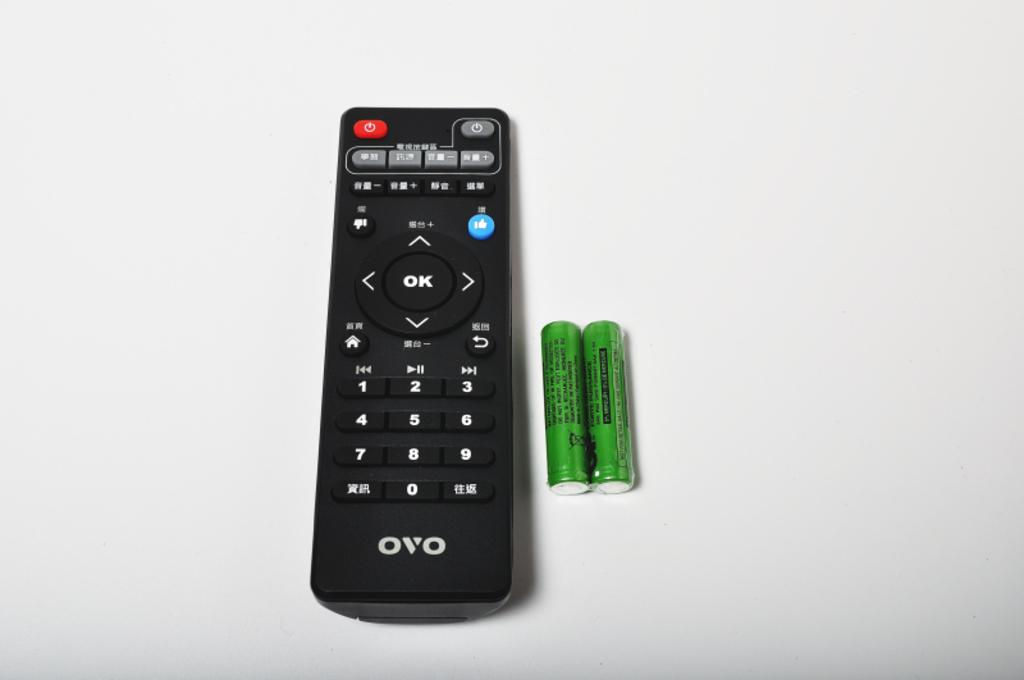<image>
Present a compact description of the photo's key features. A remote by OVO sits on a white surface next to two green batteries. 